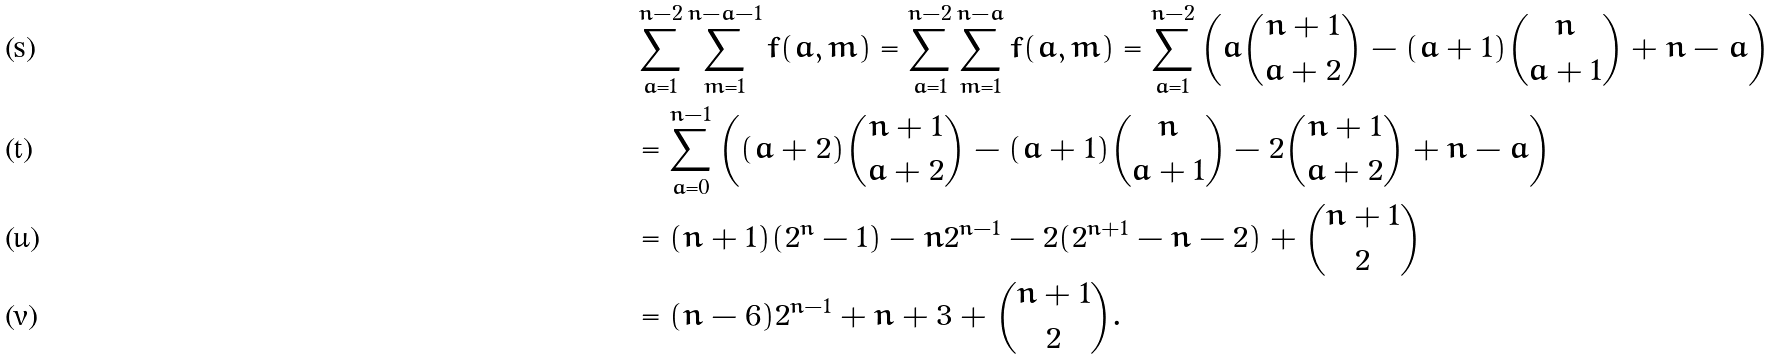Convert formula to latex. <formula><loc_0><loc_0><loc_500><loc_500>& \sum _ { a = 1 } ^ { n - 2 } \sum _ { m = 1 } ^ { n - a - 1 } f ( a , m ) = \sum _ { a = 1 } ^ { n - 2 } \sum _ { m = 1 } ^ { n - a } f ( a , m ) = \sum _ { a = 1 } ^ { n - 2 } \left ( a \binom { n + 1 } { a + 2 } - ( a + 1 ) \binom { n } { a + 1 } + n - a \right ) \\ & = \sum _ { a = 0 } ^ { n - 1 } \left ( ( a + 2 ) \binom { n + 1 } { a + 2 } - ( a + 1 ) \binom { n } { a + 1 } - 2 \binom { n + 1 } { a + 2 } + n - a \right ) \\ & = ( n + 1 ) ( 2 ^ { n } - 1 ) - n 2 ^ { n - 1 } - 2 ( 2 ^ { n + 1 } - n - 2 ) + \binom { n + 1 } { 2 } \\ & = ( n - 6 ) 2 ^ { n - 1 } + n + 3 + \binom { n + 1 } { 2 } .</formula> 